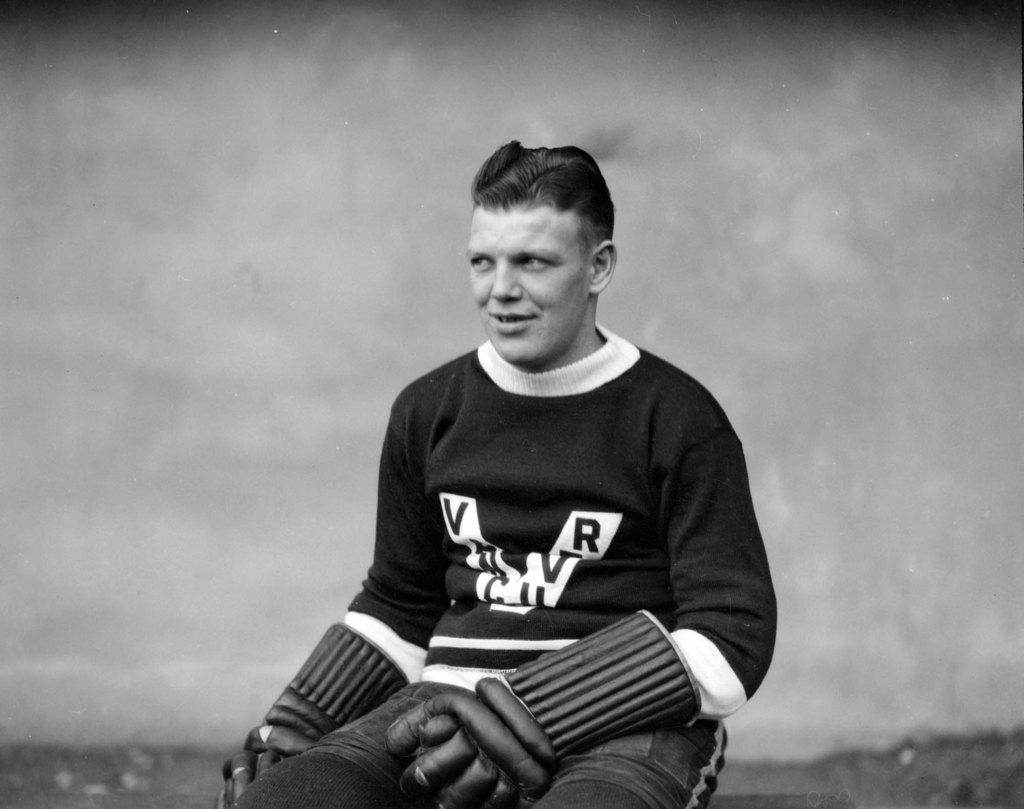What letter is on his jacket?
Provide a succinct answer. V. 